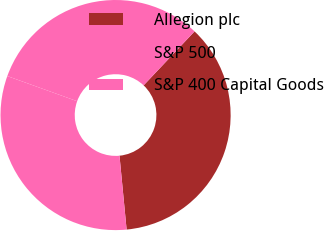Convert chart to OTSL. <chart><loc_0><loc_0><loc_500><loc_500><pie_chart><fcel>Allegion plc<fcel>S&P 500<fcel>S&P 400 Capital Goods<nl><fcel>36.43%<fcel>32.03%<fcel>31.54%<nl></chart> 